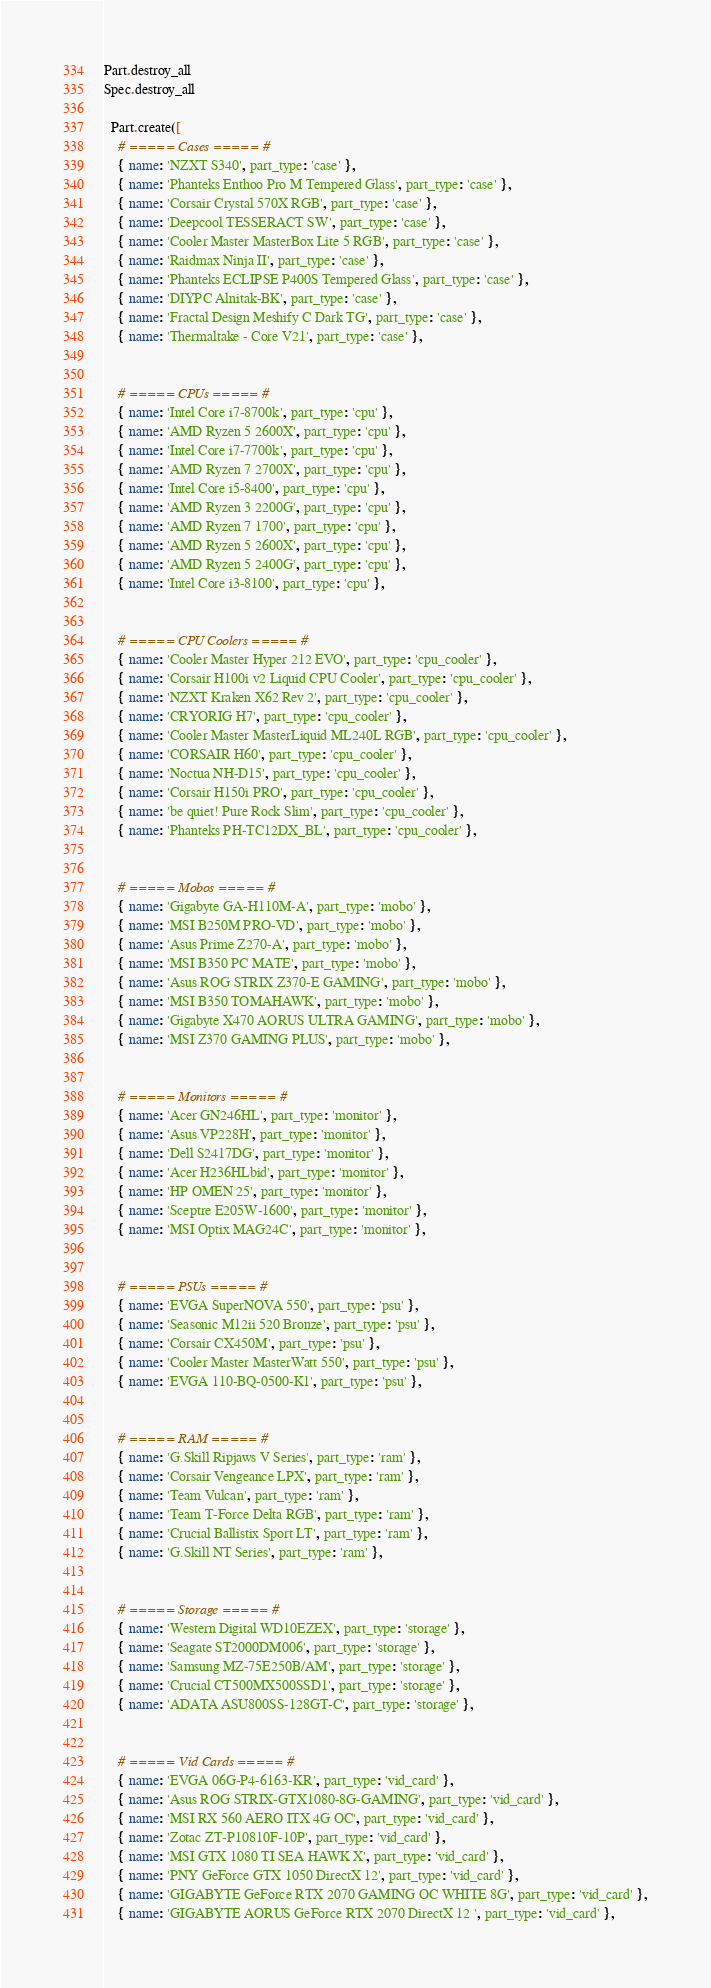Convert code to text. <code><loc_0><loc_0><loc_500><loc_500><_Ruby_>Part.destroy_all
Spec.destroy_all

  Part.create([
    # ===== Cases ===== #
    { name: 'NZXT S340', part_type: 'case' },
    { name: 'Phanteks Enthoo Pro M Tempered Glass', part_type: 'case' },
    { name: 'Corsair Crystal 570X RGB', part_type: 'case' },
    { name: 'Deepcool TESSERACT SW', part_type: 'case' },
    { name: 'Cooler Master MasterBox Lite 5 RGB', part_type: 'case' },
    { name: 'Raidmax Ninja II', part_type: 'case' },
    { name: 'Phanteks ECLIPSE P400S Tempered Glass', part_type: 'case' },
    { name: 'DIYPC Alnitak-BK', part_type: 'case' },
    { name: 'Fractal Design Meshify C Dark TG', part_type: 'case' },
    { name: 'Thermaltake - Core V21', part_type: 'case' },


    # ===== CPUs ===== #
    { name: 'Intel Core i7-8700k', part_type: 'cpu' },
    { name: 'AMD Ryzen 5 2600X', part_type: 'cpu' },
    { name: 'Intel Core i7-7700k', part_type: 'cpu' },
    { name: 'AMD Ryzen 7 2700X', part_type: 'cpu' },
    { name: 'Intel Core i5-8400', part_type: 'cpu' },
    { name: 'AMD Ryzen 3 2200G', part_type: 'cpu' },
    { name: 'AMD Ryzen 7 1700', part_type: 'cpu' },
    { name: 'AMD Ryzen 5 2600X', part_type: 'cpu' },
    { name: 'AMD Ryzen 5 2400G', part_type: 'cpu' },
    { name: 'Intel Core i3-8100', part_type: 'cpu' },


    # ===== CPU Coolers ===== #
    { name: 'Cooler Master Hyper 212 EVO', part_type: 'cpu_cooler' },
    { name: 'Corsair H100i v2 Liquid CPU Cooler', part_type: 'cpu_cooler' },
    { name: 'NZXT Kraken X62 Rev 2', part_type: 'cpu_cooler' },
    { name: 'CRYORIG H7', part_type: 'cpu_cooler' },
    { name: 'Cooler Master MasterLiquid ML240L RGB', part_type: 'cpu_cooler' },
    { name: 'CORSAIR H60', part_type: 'cpu_cooler' },
    { name: 'Noctua NH-D15', part_type: 'cpu_cooler' },
    { name: 'Corsair H150i PRO', part_type: 'cpu_cooler' },
    { name: 'be quiet! Pure Rock Slim', part_type: 'cpu_cooler' },
    { name: 'Phanteks PH-TC12DX_BL', part_type: 'cpu_cooler' },


    # ===== Mobos ===== #
    { name: 'Gigabyte GA-H110M-A', part_type: 'mobo' },
    { name: 'MSI B250M PRO-VD', part_type: 'mobo' },
    { name: 'Asus Prime Z270-A', part_type: 'mobo' },
    { name: 'MSI B350 PC MATE', part_type: 'mobo' },
    { name: 'Asus ROG STRIX Z370-E GAMING', part_type: 'mobo' },
    { name: 'MSI B350 TOMAHAWK', part_type: 'mobo' },
    { name: 'Gigabyte X470 AORUS ULTRA GAMING', part_type: 'mobo' },
    { name: 'MSI Z370 GAMING PLUS', part_type: 'mobo' },


    # ===== Monitors ===== #
    { name: 'Acer GN246HL', part_type: 'monitor' },
    { name: 'Asus VP228H', part_type: 'monitor' },
    { name: 'Dell S2417DG', part_type: 'monitor' },
    { name: 'Acer H236HLbid', part_type: 'monitor' },
    { name: 'HP OMEN 25', part_type: 'monitor' },
    { name: 'Sceptre E205W-1600', part_type: 'monitor' },
    { name: 'MSI Optix MAG24C', part_type: 'monitor' },


    # ===== PSUs ===== #
    { name: 'EVGA SuperNOVA 550', part_type: 'psu' },
    { name: 'Seasonic M12ii 520 Bronze', part_type: 'psu' },
    { name: 'Corsair CX450M', part_type: 'psu' },
    { name: 'Cooler Master MasterWatt 550', part_type: 'psu' },
    { name: 'EVGA 110-BQ-0500-K1', part_type: 'psu' },


    # ===== RAM ===== #
    { name: 'G.Skill Ripjaws V Series', part_type: 'ram' },
    { name: 'Corsair Vengeance LPX', part_type: 'ram' },
    { name: 'Team Vulcan', part_type: 'ram' },
    { name: 'Team T-Force Delta RGB', part_type: 'ram' },
    { name: 'Crucial Ballistix Sport LT', part_type: 'ram' },
    { name: 'G.Skill NT Series', part_type: 'ram' },


    # ===== Storage ===== #
    { name: 'Western Digital WD10EZEX', part_type: 'storage' },
    { name: 'Seagate ST2000DM006', part_type: 'storage' },
    { name: 'Samsung MZ-75E250B/AM', part_type: 'storage' },
    { name: 'Crucial CT500MX500SSD1', part_type: 'storage' },
    { name: 'ADATA ASU800SS-128GT-C', part_type: 'storage' },


    # ===== Vid Cards ===== #
    { name: 'EVGA 06G-P4-6163-KR', part_type: 'vid_card' },
    { name: 'Asus ROG STRIX-GTX1080-8G-GAMING', part_type: 'vid_card' },
    { name: 'MSI RX 560 AERO ITX 4G OC', part_type: 'vid_card' },
    { name: 'Zotac ZT-P10810F-10P', part_type: 'vid_card' },
    { name: 'MSI GTX 1080 TI SEA HAWK X', part_type: 'vid_card' },
    { name: 'PNY GeForce GTX 1050 DirectX 12', part_type: 'vid_card' },
    { name: 'GIGABYTE GeForce RTX 2070 GAMING OC WHITE 8G', part_type: 'vid_card' },
    { name: 'GIGABYTE AORUS GeForce RTX 2070 DirectX 12 ', part_type: 'vid_card' },</code> 